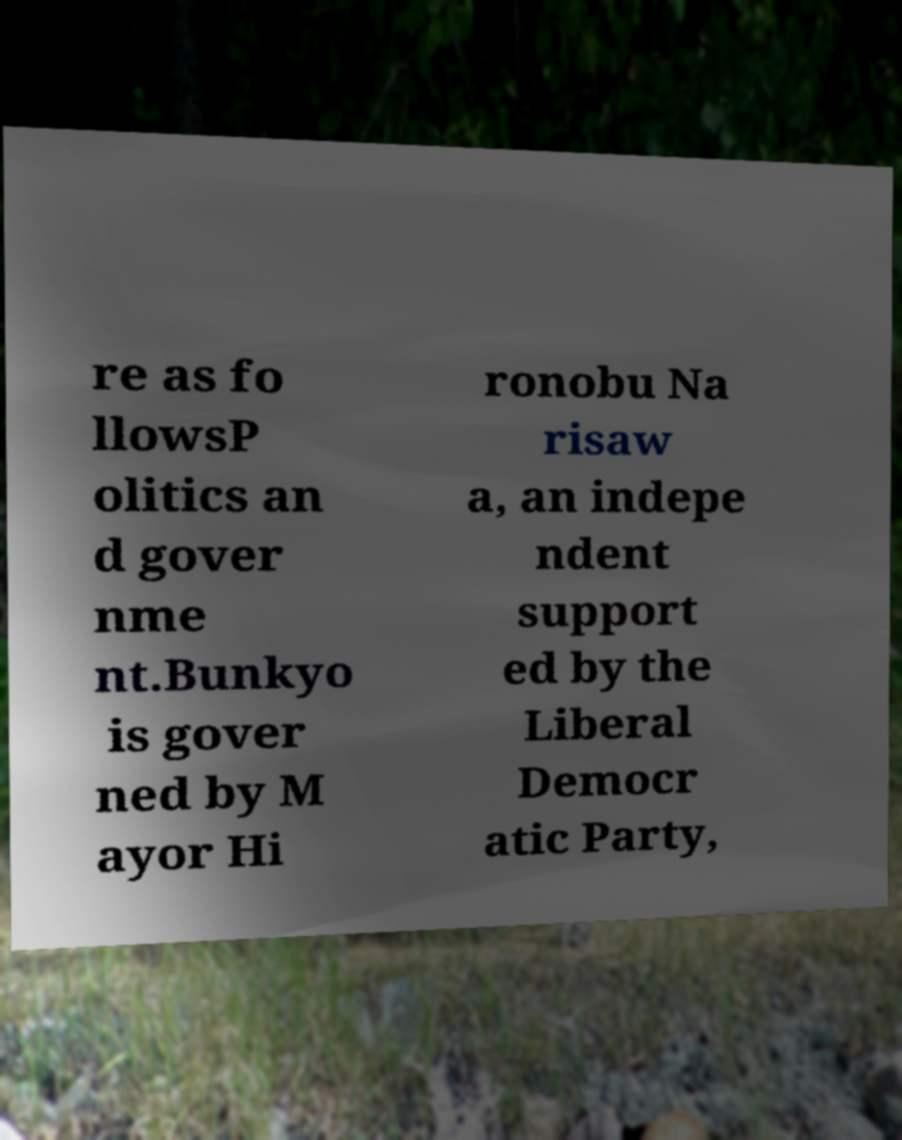For documentation purposes, I need the text within this image transcribed. Could you provide that? re as fo llowsP olitics an d gover nme nt.Bunkyo is gover ned by M ayor Hi ronobu Na risaw a, an indepe ndent support ed by the Liberal Democr atic Party, 